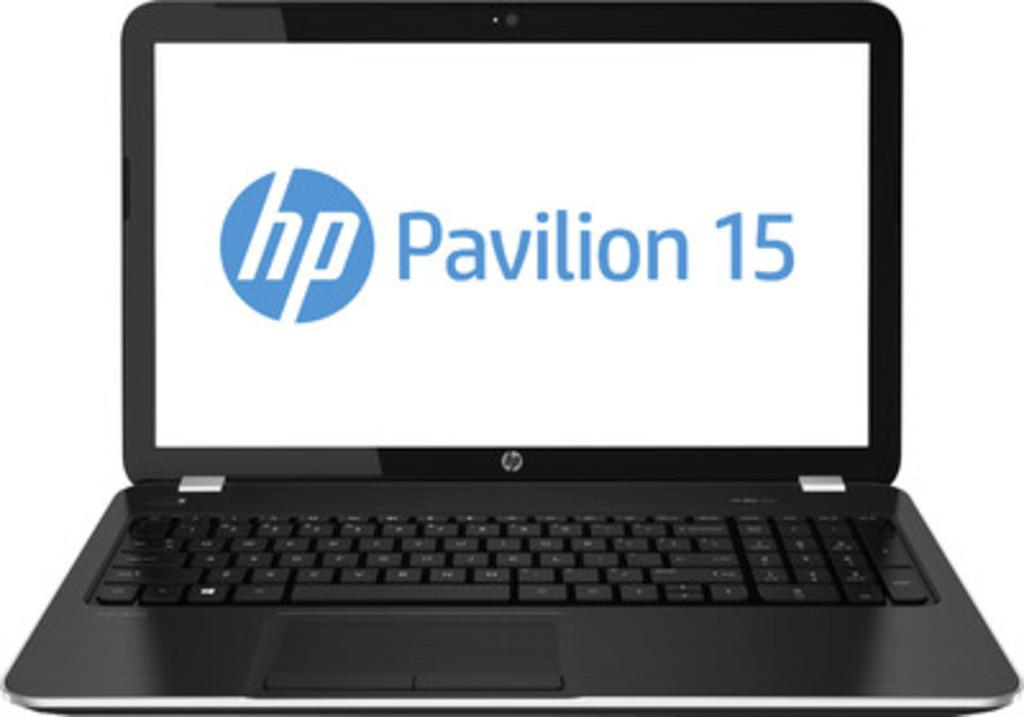Provide a one-sentence caption for the provided image. A laptop open with hp pavilion 15 on its screen. 